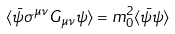Convert formula to latex. <formula><loc_0><loc_0><loc_500><loc_500>\langle \bar { \psi } \sigma ^ { \mu \nu } G _ { \mu \nu } \psi \rangle = m _ { 0 } ^ { 2 } \langle \bar { \psi } \psi \rangle</formula> 